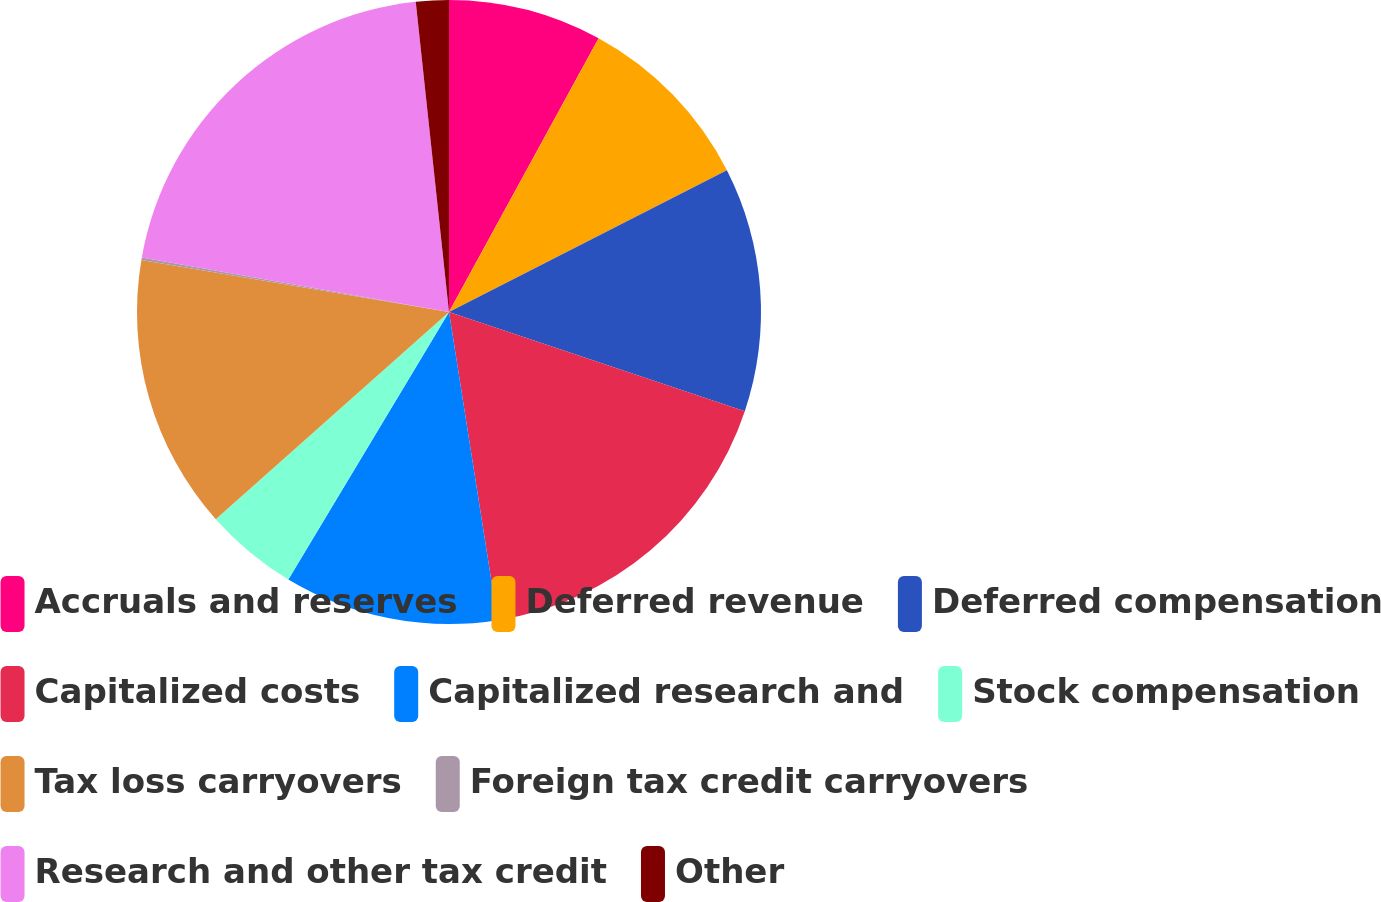Convert chart. <chart><loc_0><loc_0><loc_500><loc_500><pie_chart><fcel>Accruals and reserves<fcel>Deferred revenue<fcel>Deferred compensation<fcel>Capitalized costs<fcel>Capitalized research and<fcel>Stock compensation<fcel>Tax loss carryovers<fcel>Foreign tax credit carryovers<fcel>Research and other tax credit<fcel>Other<nl><fcel>7.96%<fcel>9.53%<fcel>12.66%<fcel>17.36%<fcel>11.1%<fcel>4.83%<fcel>14.23%<fcel>0.13%<fcel>20.5%<fcel>1.7%<nl></chart> 